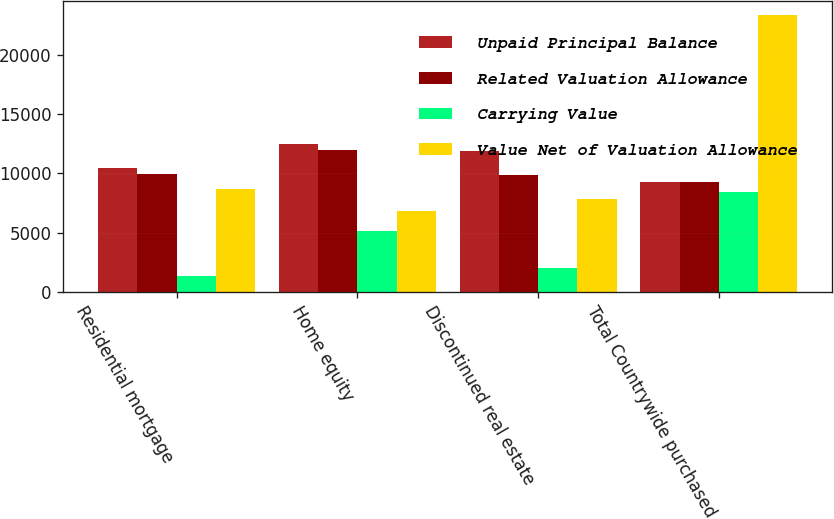<chart> <loc_0><loc_0><loc_500><loc_500><stacked_bar_chart><ecel><fcel>Residential mortgage<fcel>Home equity<fcel>Discontinued real estate<fcel>Total Countrywide purchased<nl><fcel>Unpaid Principal Balance<fcel>10426<fcel>12516<fcel>11891<fcel>9246<nl><fcel>Related Valuation Allowance<fcel>9966<fcel>11978<fcel>9857<fcel>9246<nl><fcel>Carrying Value<fcel>1331<fcel>5129<fcel>1999<fcel>8459<nl><fcel>Value Net of Valuation Allowance<fcel>8635<fcel>6849<fcel>7858<fcel>23342<nl></chart> 